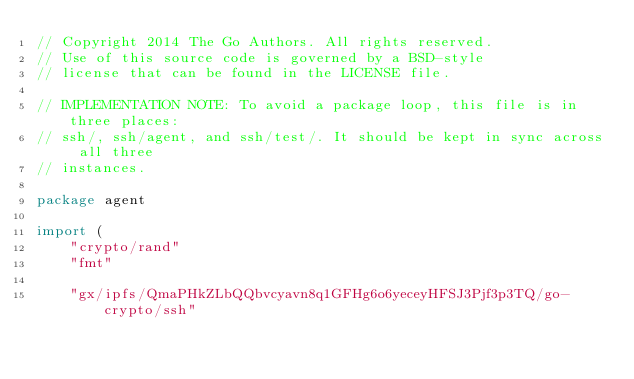<code> <loc_0><loc_0><loc_500><loc_500><_Go_>// Copyright 2014 The Go Authors. All rights reserved.
// Use of this source code is governed by a BSD-style
// license that can be found in the LICENSE file.

// IMPLEMENTATION NOTE: To avoid a package loop, this file is in three places:
// ssh/, ssh/agent, and ssh/test/. It should be kept in sync across all three
// instances.

package agent

import (
	"crypto/rand"
	"fmt"

	"gx/ipfs/QmaPHkZLbQQbvcyavn8q1GFHg6o6yeceyHFSJ3Pjf3p3TQ/go-crypto/ssh"</code> 